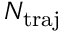Convert formula to latex. <formula><loc_0><loc_0><loc_500><loc_500>N _ { t r a j }</formula> 